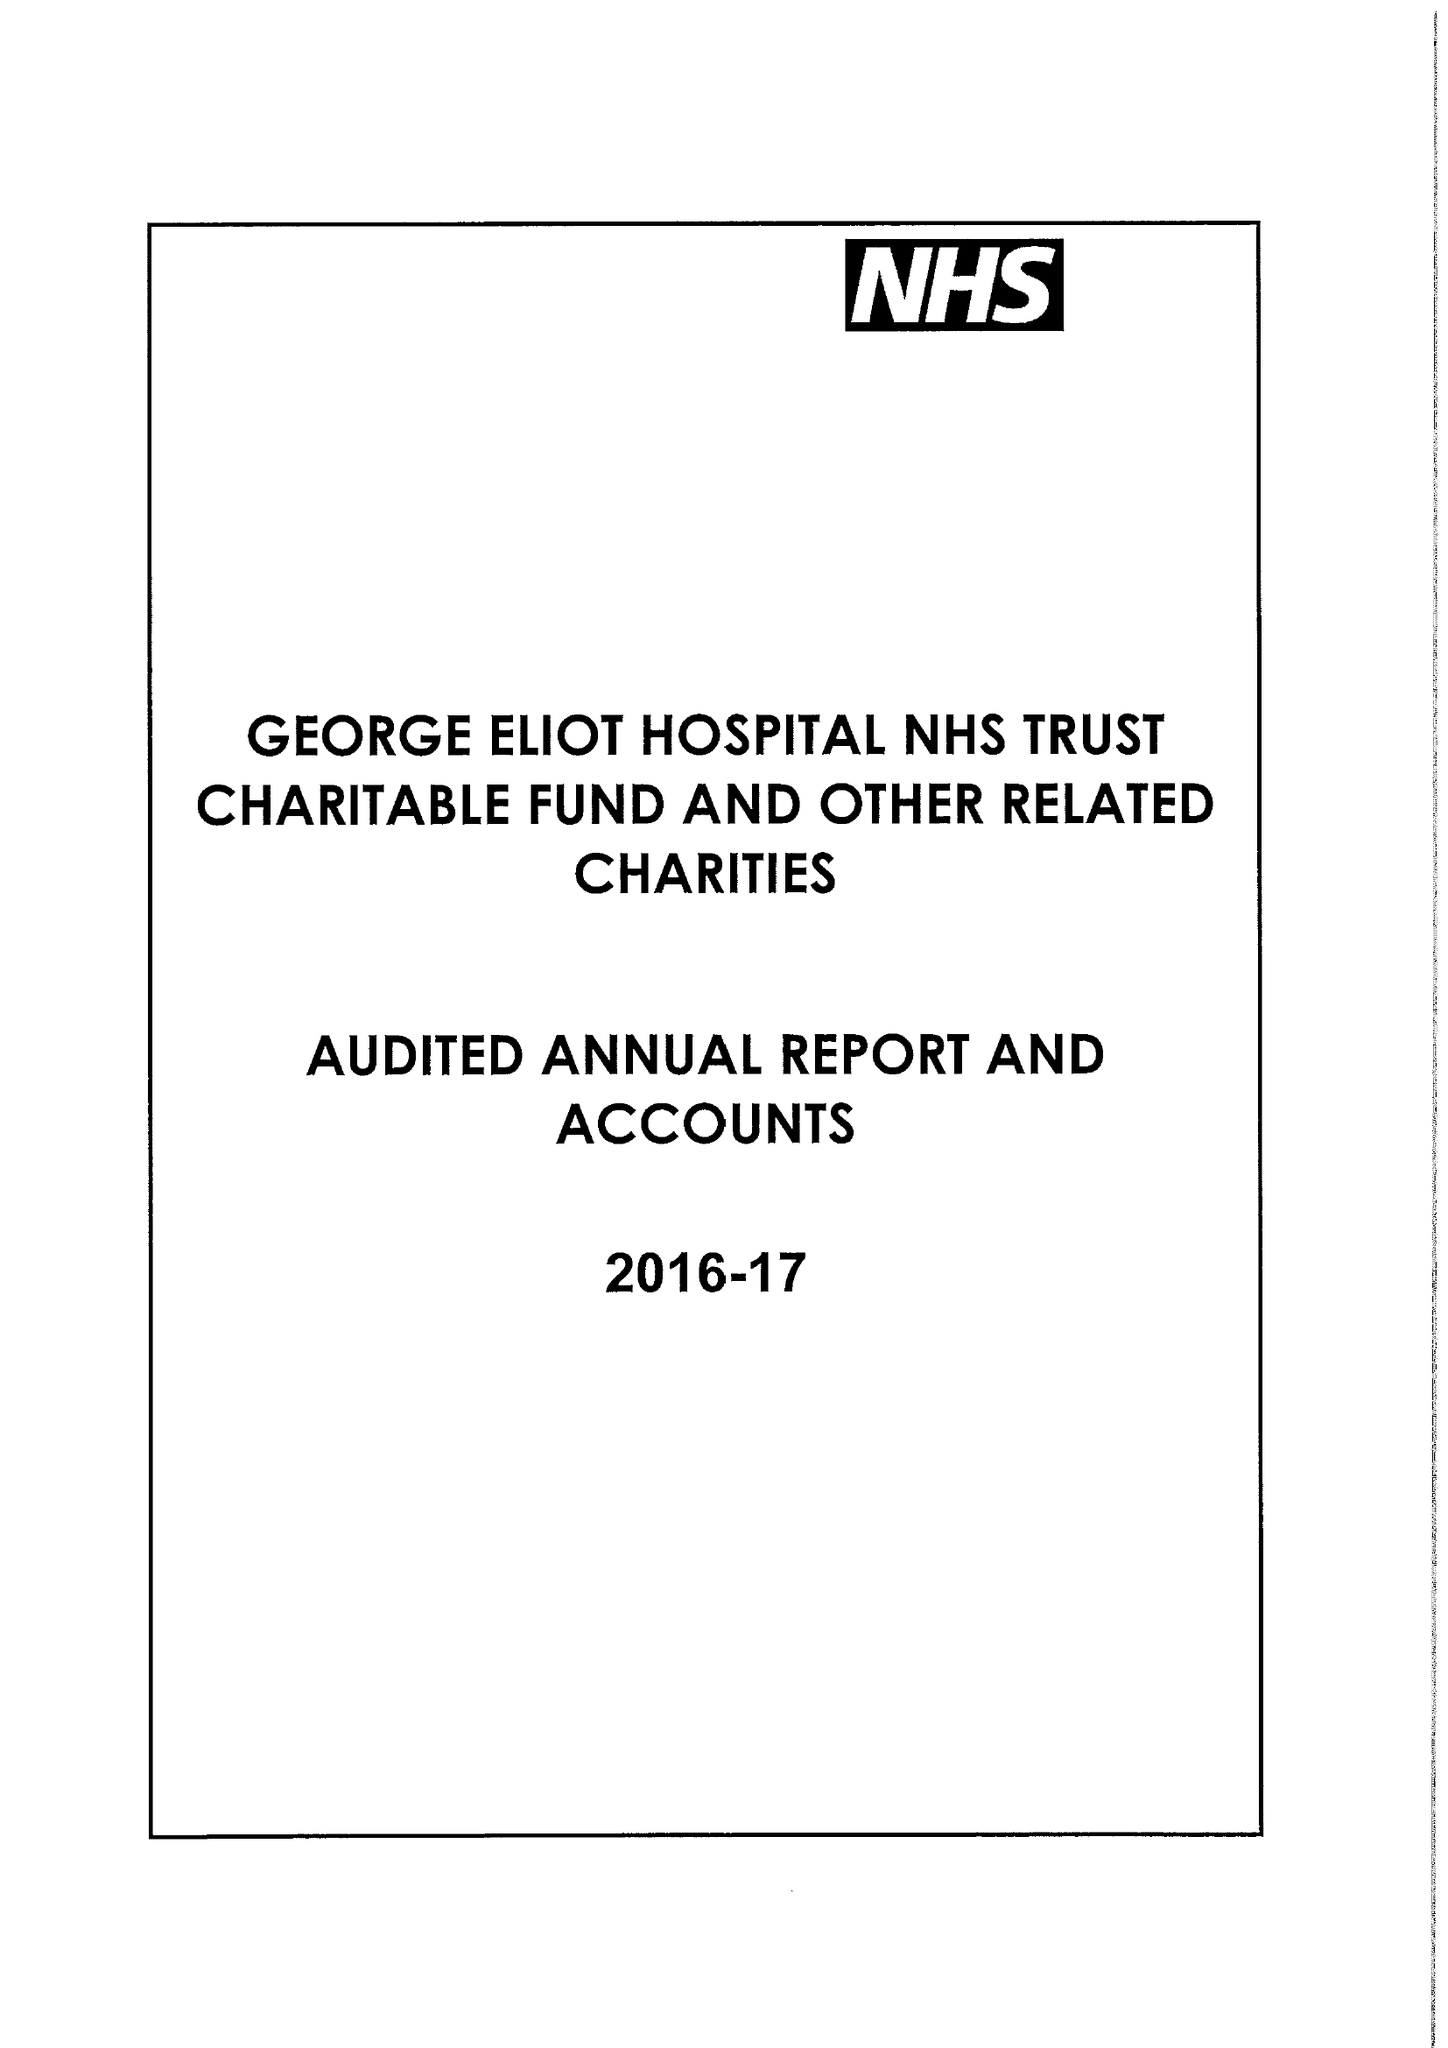What is the value for the charity_number?
Answer the question using a single word or phrase. 1057607 